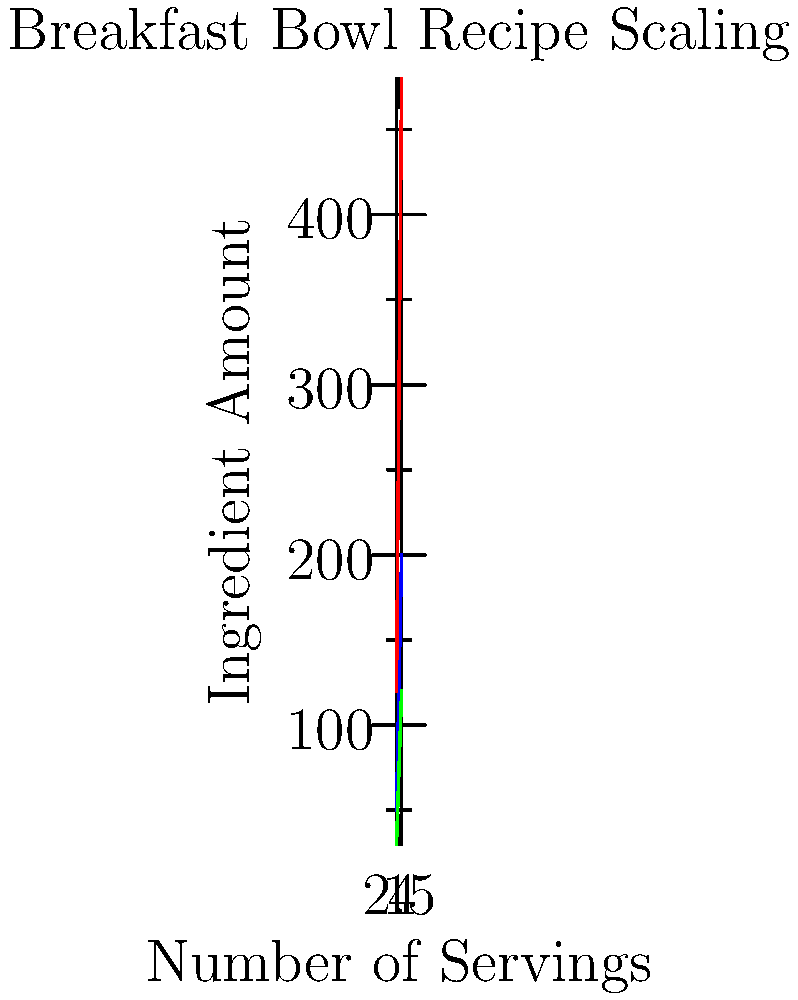You're developing a new breakfast bowl recipe for your blog. The graph shows how the amounts of oats, milk, and berries scale with the number of servings. If you want to make a batch for 6 servings, what would be the ingredient vector $\vec{v}$ in the form $(oats, milk, berries)$? Let's approach this step-by-step:

1) First, we need to identify the pattern for each ingredient:
   - Oats: Increases by 50g per serving
   - Milk: Increases by 120ml per serving
   - Berries: Increases by 30g per serving

2) Now, let's calculate the amount for each ingredient for 6 servings:

   Oats: $50g \times 6 = 300g$
   Milk: $120ml \times 6 = 720ml$
   Berries: $30g \times 6 = 180g$

3) We can represent this as a vector $\vec{v}$ in the form $(oats, milk, berries)$

Therefore, the ingredient vector for 6 servings is $\vec{v} = (300, 720, 180)$.
Answer: $\vec{v} = (300, 720, 180)$ 